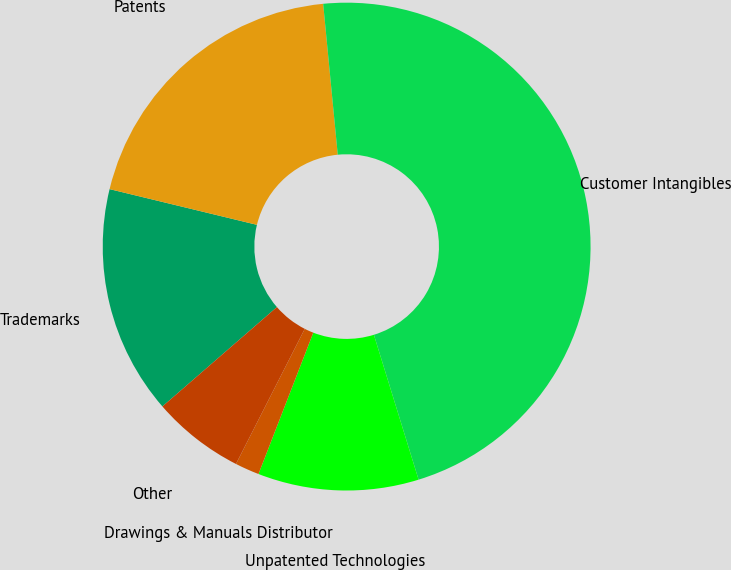Convert chart. <chart><loc_0><loc_0><loc_500><loc_500><pie_chart><fcel>Trademarks<fcel>Patents<fcel>Customer Intangibles<fcel>Unpatented Technologies<fcel>Drawings & Manuals Distributor<fcel>Other<nl><fcel>15.16%<fcel>19.68%<fcel>46.77%<fcel>10.65%<fcel>1.61%<fcel>6.13%<nl></chart> 